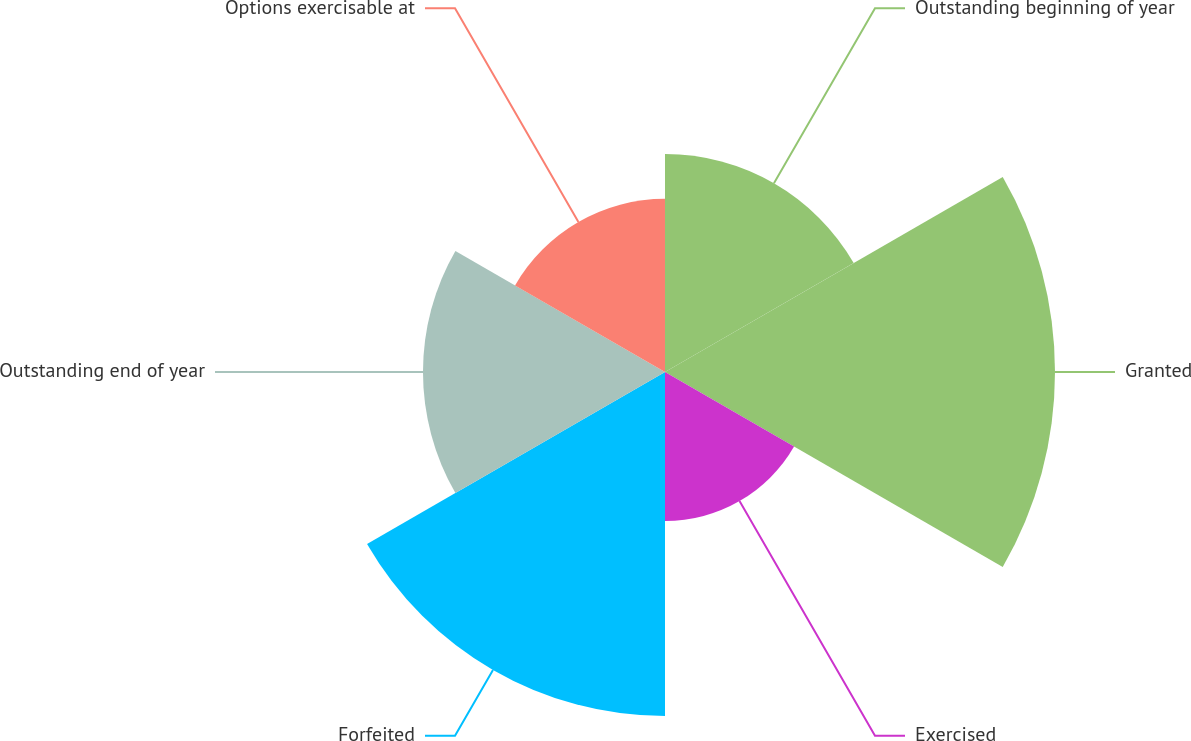<chart> <loc_0><loc_0><loc_500><loc_500><pie_chart><fcel>Outstanding beginning of year<fcel>Granted<fcel>Exercised<fcel>Forfeited<fcel>Outstanding end of year<fcel>Options exercisable at<nl><fcel>14.37%<fcel>25.72%<fcel>9.83%<fcel>22.69%<fcel>15.96%<fcel>11.42%<nl></chart> 